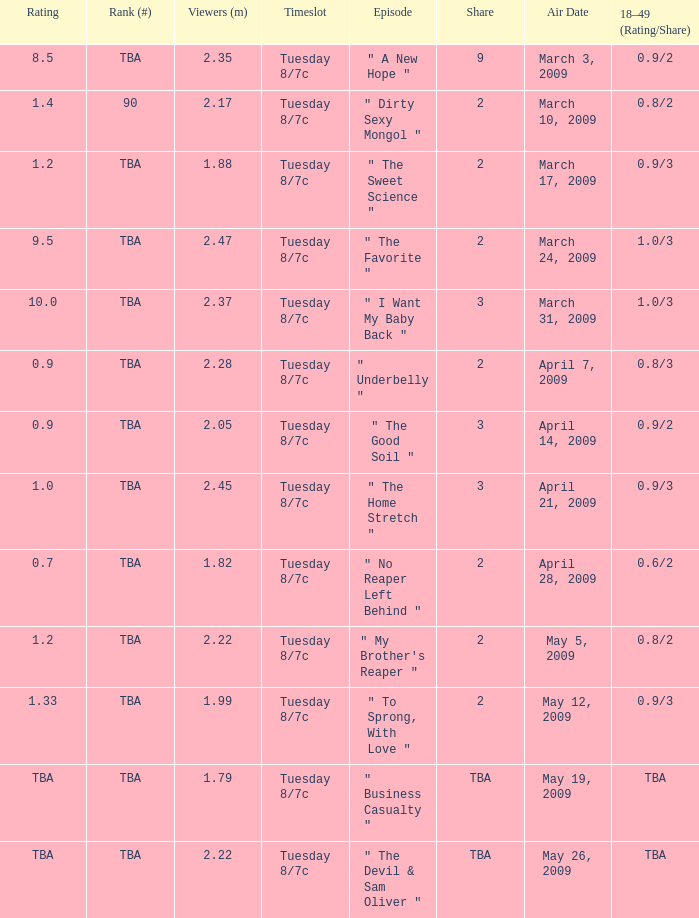What is the rank for the show aired on May 19, 2009? TBA. 